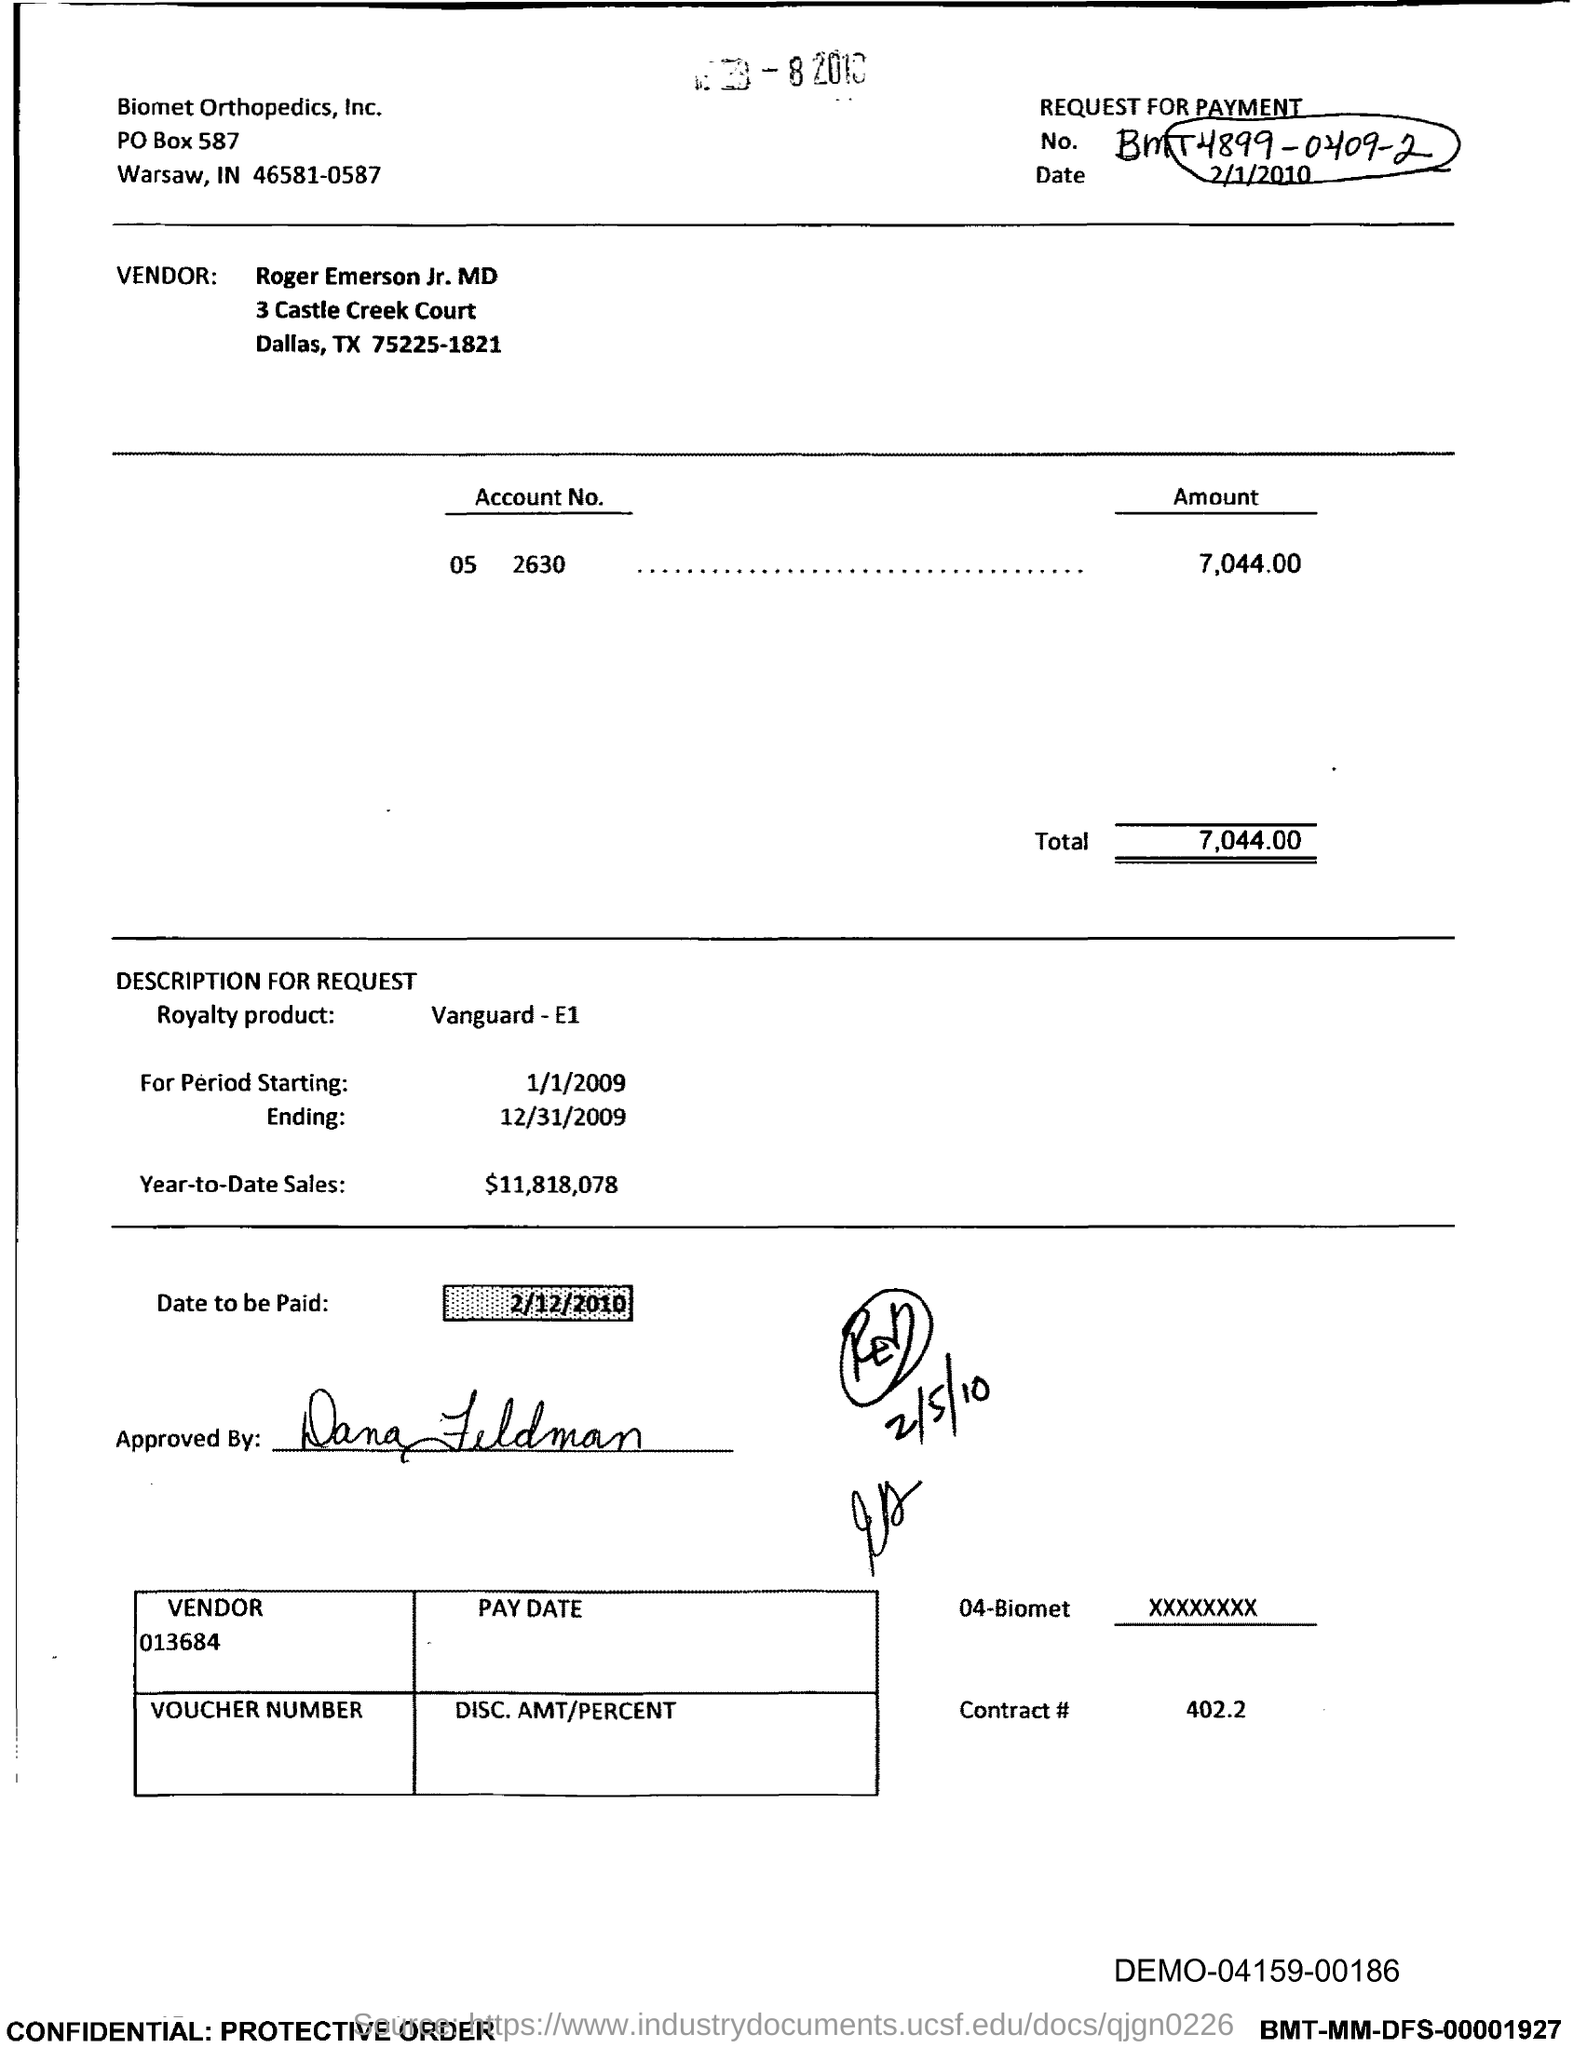Identify some key points in this picture. Biomet Orthopedics, Inc. is located in the state of Indiana. I am requesting the contract number, which is 402.2. The date to be paid is February 12, 2010. As of this point in the year, the total sales for the year-to-date are $11,818,078. The total is 7,044.00. 